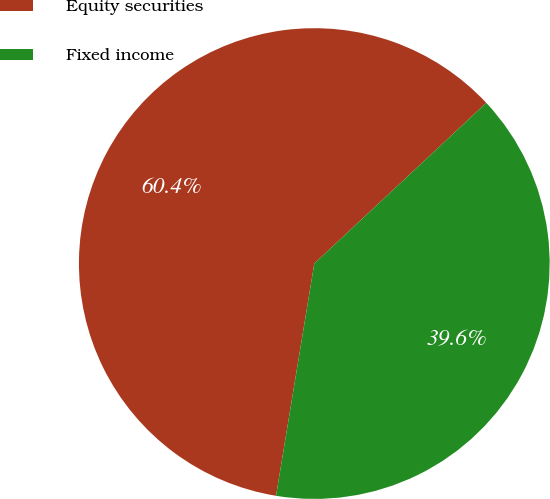Convert chart. <chart><loc_0><loc_0><loc_500><loc_500><pie_chart><fcel>Equity securities<fcel>Fixed income<nl><fcel>60.44%<fcel>39.56%<nl></chart> 